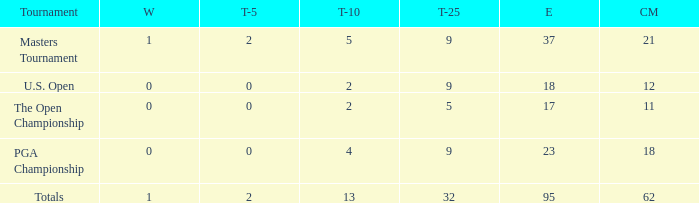What is the average number of cuts made in the Top 25 smaller than 5? None. 